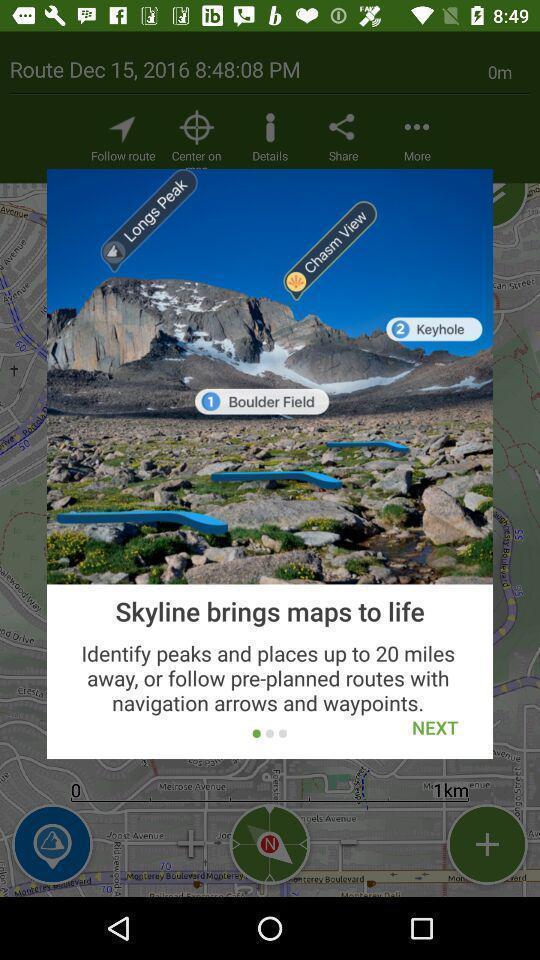Provide a description of this screenshot. Pop-up shows next option to continue with navigation app. 